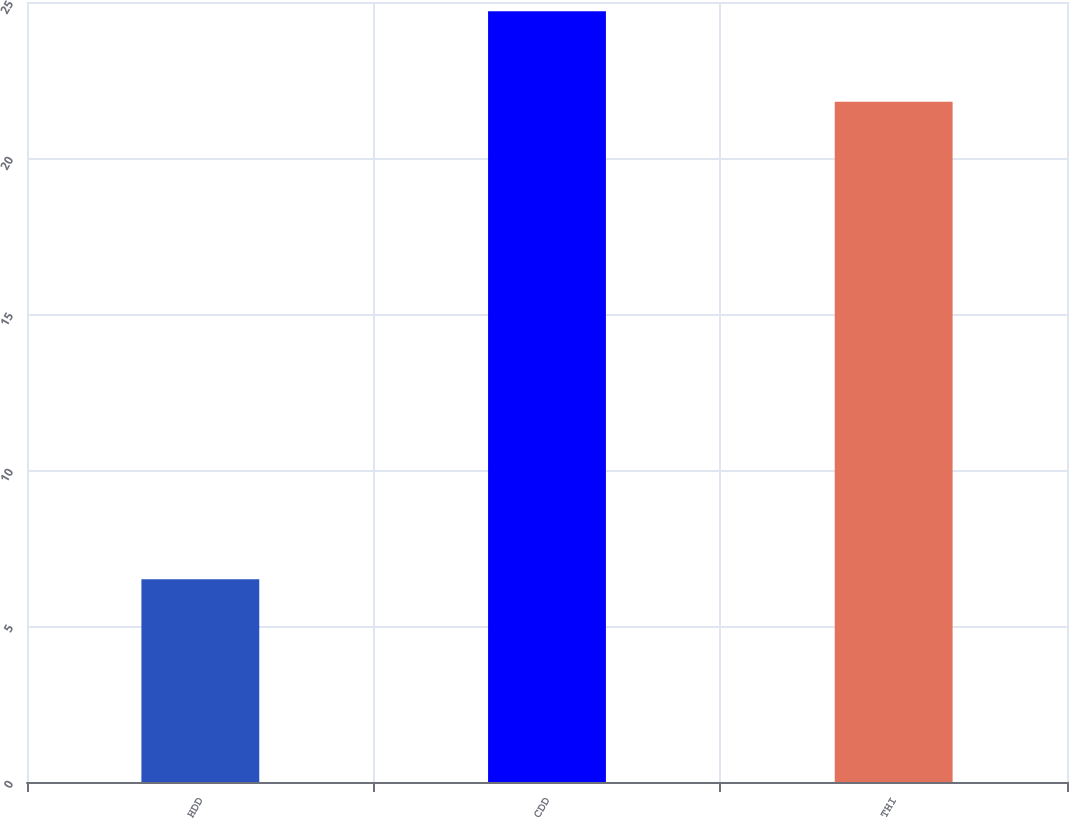Convert chart. <chart><loc_0><loc_0><loc_500><loc_500><bar_chart><fcel>HDD<fcel>CDD<fcel>THI<nl><fcel>6.5<fcel>24.7<fcel>21.8<nl></chart> 